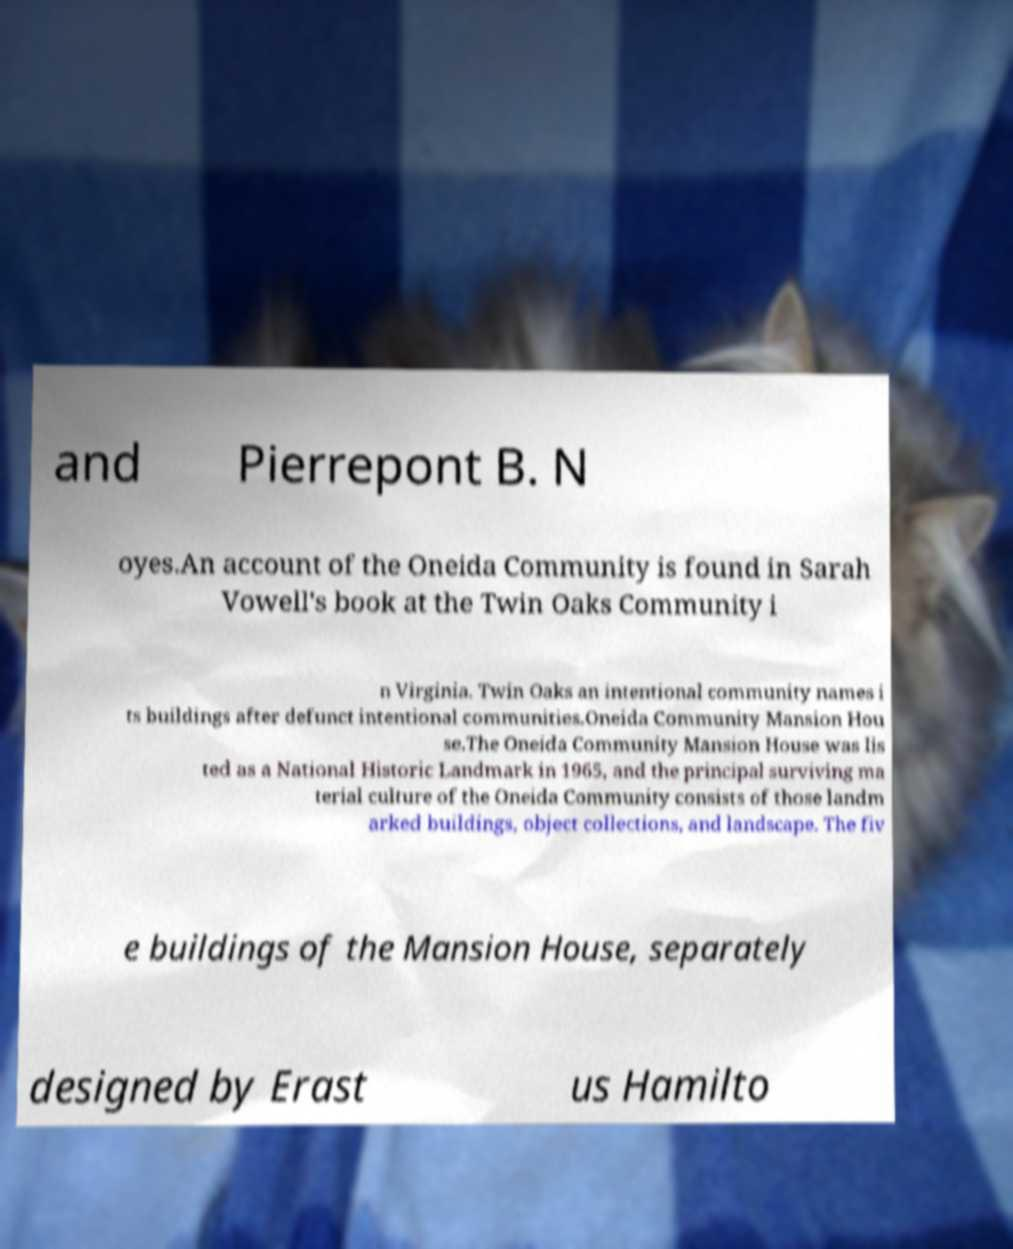Please identify and transcribe the text found in this image. and Pierrepont B. N oyes.An account of the Oneida Community is found in Sarah Vowell's book at the Twin Oaks Community i n Virginia. Twin Oaks an intentional community names i ts buildings after defunct intentional communities.Oneida Community Mansion Hou se.The Oneida Community Mansion House was lis ted as a National Historic Landmark in 1965, and the principal surviving ma terial culture of the Oneida Community consists of those landm arked buildings, object collections, and landscape. The fiv e buildings of the Mansion House, separately designed by Erast us Hamilto 